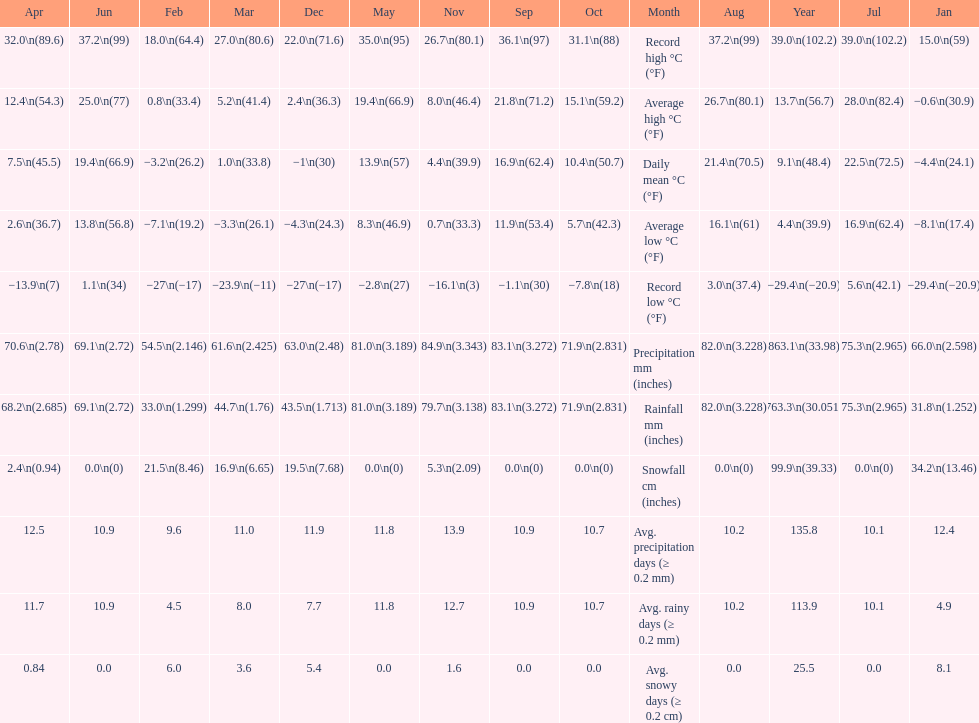Could you parse the entire table as a dict? {'header': ['Apr', 'Jun', 'Feb', 'Mar', 'Dec', 'May', 'Nov', 'Sep', 'Oct', 'Month', 'Aug', 'Year', 'Jul', 'Jan'], 'rows': [['32.0\\n(89.6)', '37.2\\n(99)', '18.0\\n(64.4)', '27.0\\n(80.6)', '22.0\\n(71.6)', '35.0\\n(95)', '26.7\\n(80.1)', '36.1\\n(97)', '31.1\\n(88)', 'Record high °C (°F)', '37.2\\n(99)', '39.0\\n(102.2)', '39.0\\n(102.2)', '15.0\\n(59)'], ['12.4\\n(54.3)', '25.0\\n(77)', '0.8\\n(33.4)', '5.2\\n(41.4)', '2.4\\n(36.3)', '19.4\\n(66.9)', '8.0\\n(46.4)', '21.8\\n(71.2)', '15.1\\n(59.2)', 'Average high °C (°F)', '26.7\\n(80.1)', '13.7\\n(56.7)', '28.0\\n(82.4)', '−0.6\\n(30.9)'], ['7.5\\n(45.5)', '19.4\\n(66.9)', '−3.2\\n(26.2)', '1.0\\n(33.8)', '−1\\n(30)', '13.9\\n(57)', '4.4\\n(39.9)', '16.9\\n(62.4)', '10.4\\n(50.7)', 'Daily mean °C (°F)', '21.4\\n(70.5)', '9.1\\n(48.4)', '22.5\\n(72.5)', '−4.4\\n(24.1)'], ['2.6\\n(36.7)', '13.8\\n(56.8)', '−7.1\\n(19.2)', '−3.3\\n(26.1)', '−4.3\\n(24.3)', '8.3\\n(46.9)', '0.7\\n(33.3)', '11.9\\n(53.4)', '5.7\\n(42.3)', 'Average low °C (°F)', '16.1\\n(61)', '4.4\\n(39.9)', '16.9\\n(62.4)', '−8.1\\n(17.4)'], ['−13.9\\n(7)', '1.1\\n(34)', '−27\\n(−17)', '−23.9\\n(−11)', '−27\\n(−17)', '−2.8\\n(27)', '−16.1\\n(3)', '−1.1\\n(30)', '−7.8\\n(18)', 'Record low °C (°F)', '3.0\\n(37.4)', '−29.4\\n(−20.9)', '5.6\\n(42.1)', '−29.4\\n(−20.9)'], ['70.6\\n(2.78)', '69.1\\n(2.72)', '54.5\\n(2.146)', '61.6\\n(2.425)', '63.0\\n(2.48)', '81.0\\n(3.189)', '84.9\\n(3.343)', '83.1\\n(3.272)', '71.9\\n(2.831)', 'Precipitation mm (inches)', '82.0\\n(3.228)', '863.1\\n(33.98)', '75.3\\n(2.965)', '66.0\\n(2.598)'], ['68.2\\n(2.685)', '69.1\\n(2.72)', '33.0\\n(1.299)', '44.7\\n(1.76)', '43.5\\n(1.713)', '81.0\\n(3.189)', '79.7\\n(3.138)', '83.1\\n(3.272)', '71.9\\n(2.831)', 'Rainfall mm (inches)', '82.0\\n(3.228)', '763.3\\n(30.051)', '75.3\\n(2.965)', '31.8\\n(1.252)'], ['2.4\\n(0.94)', '0.0\\n(0)', '21.5\\n(8.46)', '16.9\\n(6.65)', '19.5\\n(7.68)', '0.0\\n(0)', '5.3\\n(2.09)', '0.0\\n(0)', '0.0\\n(0)', 'Snowfall cm (inches)', '0.0\\n(0)', '99.9\\n(39.33)', '0.0\\n(0)', '34.2\\n(13.46)'], ['12.5', '10.9', '9.6', '11.0', '11.9', '11.8', '13.9', '10.9', '10.7', 'Avg. precipitation days (≥ 0.2 mm)', '10.2', '135.8', '10.1', '12.4'], ['11.7', '10.9', '4.5', '8.0', '7.7', '11.8', '12.7', '10.9', '10.7', 'Avg. rainy days (≥ 0.2 mm)', '10.2', '113.9', '10.1', '4.9'], ['0.84', '0.0', '6.0', '3.6', '5.4', '0.0', '1.6', '0.0', '0.0', 'Avg. snowy days (≥ 0.2 cm)', '0.0', '25.5', '0.0', '8.1']]} How many months had a record high of over 15.0 degrees? 11. 